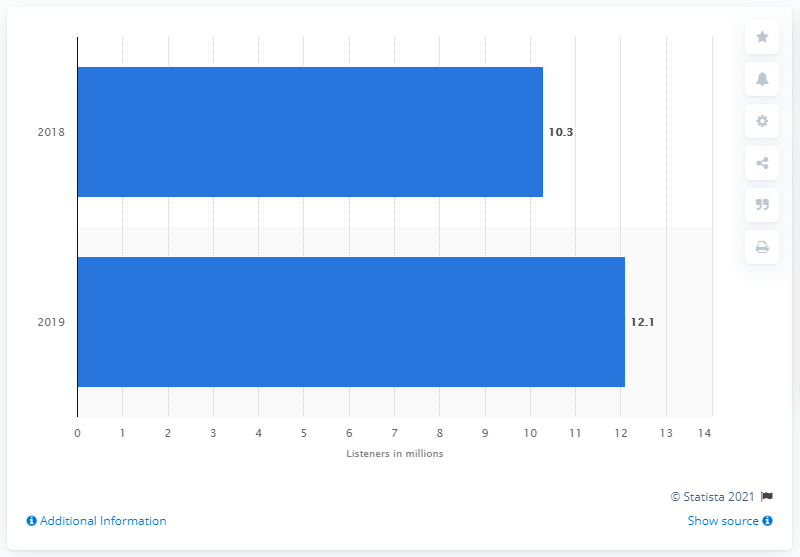Identify some key points in this picture. In 2019, the podcast audience in Italy was estimated to be 12.1 million listeners. In 2018, Italy's podcast audience numbered 10.3 million. 